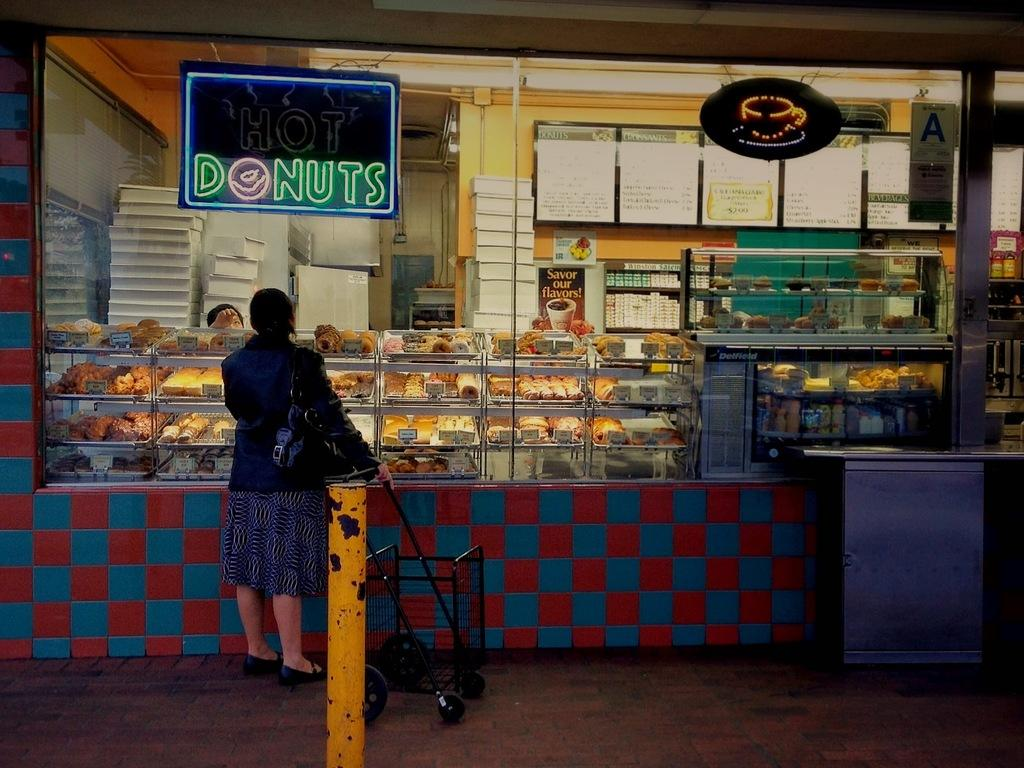<image>
Relay a brief, clear account of the picture shown. A neon sign advertising donuts hangs in front of a food business. 